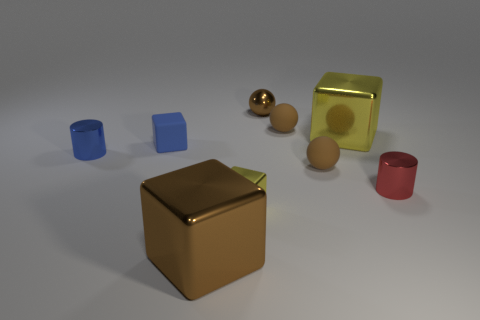There is a tiny rubber object that is the same shape as the big yellow metal object; what is its color?
Your response must be concise. Blue. Are there more tiny balls in front of the small blue cylinder than tiny cylinders that are behind the blue cube?
Make the answer very short. Yes. What size is the brown metal object in front of the cylinder left of the big yellow object that is behind the tiny red cylinder?
Make the answer very short. Large. Is the material of the big brown cube the same as the small block that is on the left side of the big brown metallic object?
Provide a succinct answer. No. Does the large brown thing have the same shape as the blue matte thing?
Ensure brevity in your answer.  Yes. What number of other things are there of the same material as the small yellow cube
Your response must be concise. 5. How many brown matte things are the same shape as the red metal thing?
Your response must be concise. 0. There is a tiny metal thing that is in front of the blue matte block and right of the tiny yellow cube; what color is it?
Your answer should be compact. Red. How many tiny blocks are there?
Keep it short and to the point. 2. Is the brown metal cube the same size as the red shiny thing?
Give a very brief answer. No. 